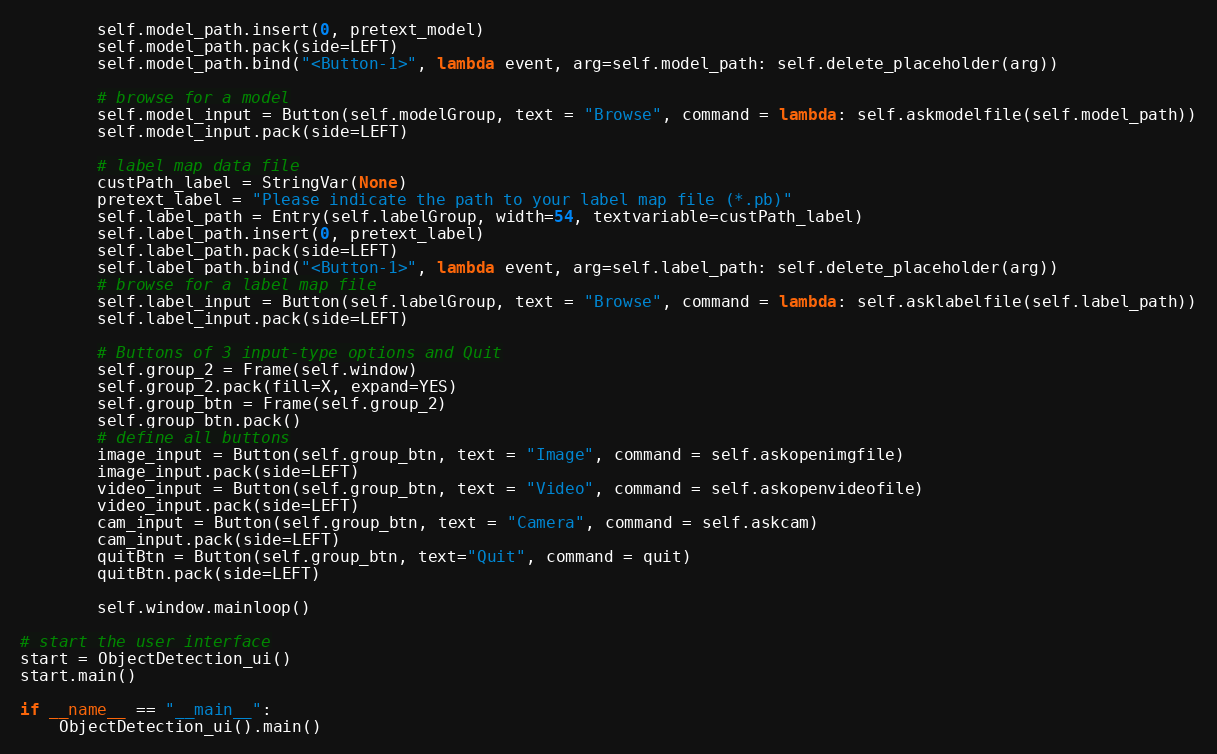<code> <loc_0><loc_0><loc_500><loc_500><_Python_>        self.model_path.insert(0, pretext_model)
        self.model_path.pack(side=LEFT)
        self.model_path.bind("<Button-1>", lambda event, arg=self.model_path: self.delete_placeholder(arg))

        # browse for a model
        self.model_input = Button(self.modelGroup, text = "Browse", command = lambda: self.askmodelfile(self.model_path))
        self.model_input.pack(side=LEFT)

        # label map data file
        custPath_label = StringVar(None)
        pretext_label = "Please indicate the path to your label map file (*.pb)"
        self.label_path = Entry(self.labelGroup, width=54, textvariable=custPath_label)
        self.label_path.insert(0, pretext_label)
        self.label_path.pack(side=LEFT)
        self.label_path.bind("<Button-1>", lambda event, arg=self.label_path: self.delete_placeholder(arg))
        # browse for a label map file
        self.label_input = Button(self.labelGroup, text = "Browse", command = lambda: self.asklabelfile(self.label_path))
        self.label_input.pack(side=LEFT)

        # Buttons of 3 input-type options and Quit
        self.group_2 = Frame(self.window)
        self.group_2.pack(fill=X, expand=YES)
        self.group_btn = Frame(self.group_2)
        self.group_btn.pack()
        # define all buttons
        image_input = Button(self.group_btn, text = "Image", command = self.askopenimgfile)
        image_input.pack(side=LEFT)
        video_input = Button(self.group_btn, text = "Video", command = self.askopenvideofile)
        video_input.pack(side=LEFT)
        cam_input = Button(self.group_btn, text = "Camera", command = self.askcam)
        cam_input.pack(side=LEFT)
        quitBtn = Button(self.group_btn, text="Quit", command = quit)
        quitBtn.pack(side=LEFT)

        self.window.mainloop()

# start the user interface
start = ObjectDetection_ui()
start.main()

if __name__ == "__main__":
    ObjectDetection_ui().main()
</code> 